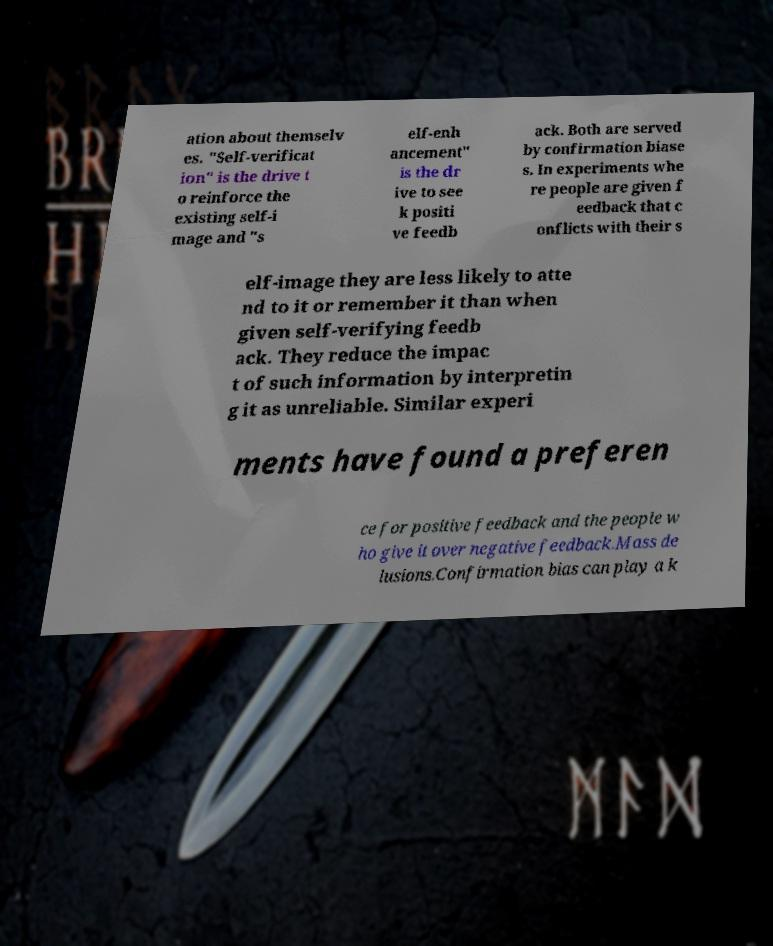Please read and relay the text visible in this image. What does it say? ation about themselv es. "Self-verificat ion" is the drive t o reinforce the existing self-i mage and "s elf-enh ancement" is the dr ive to see k positi ve feedb ack. Both are served by confirmation biase s. In experiments whe re people are given f eedback that c onflicts with their s elf-image they are less likely to atte nd to it or remember it than when given self-verifying feedb ack. They reduce the impac t of such information by interpretin g it as unreliable. Similar experi ments have found a preferen ce for positive feedback and the people w ho give it over negative feedback.Mass de lusions.Confirmation bias can play a k 